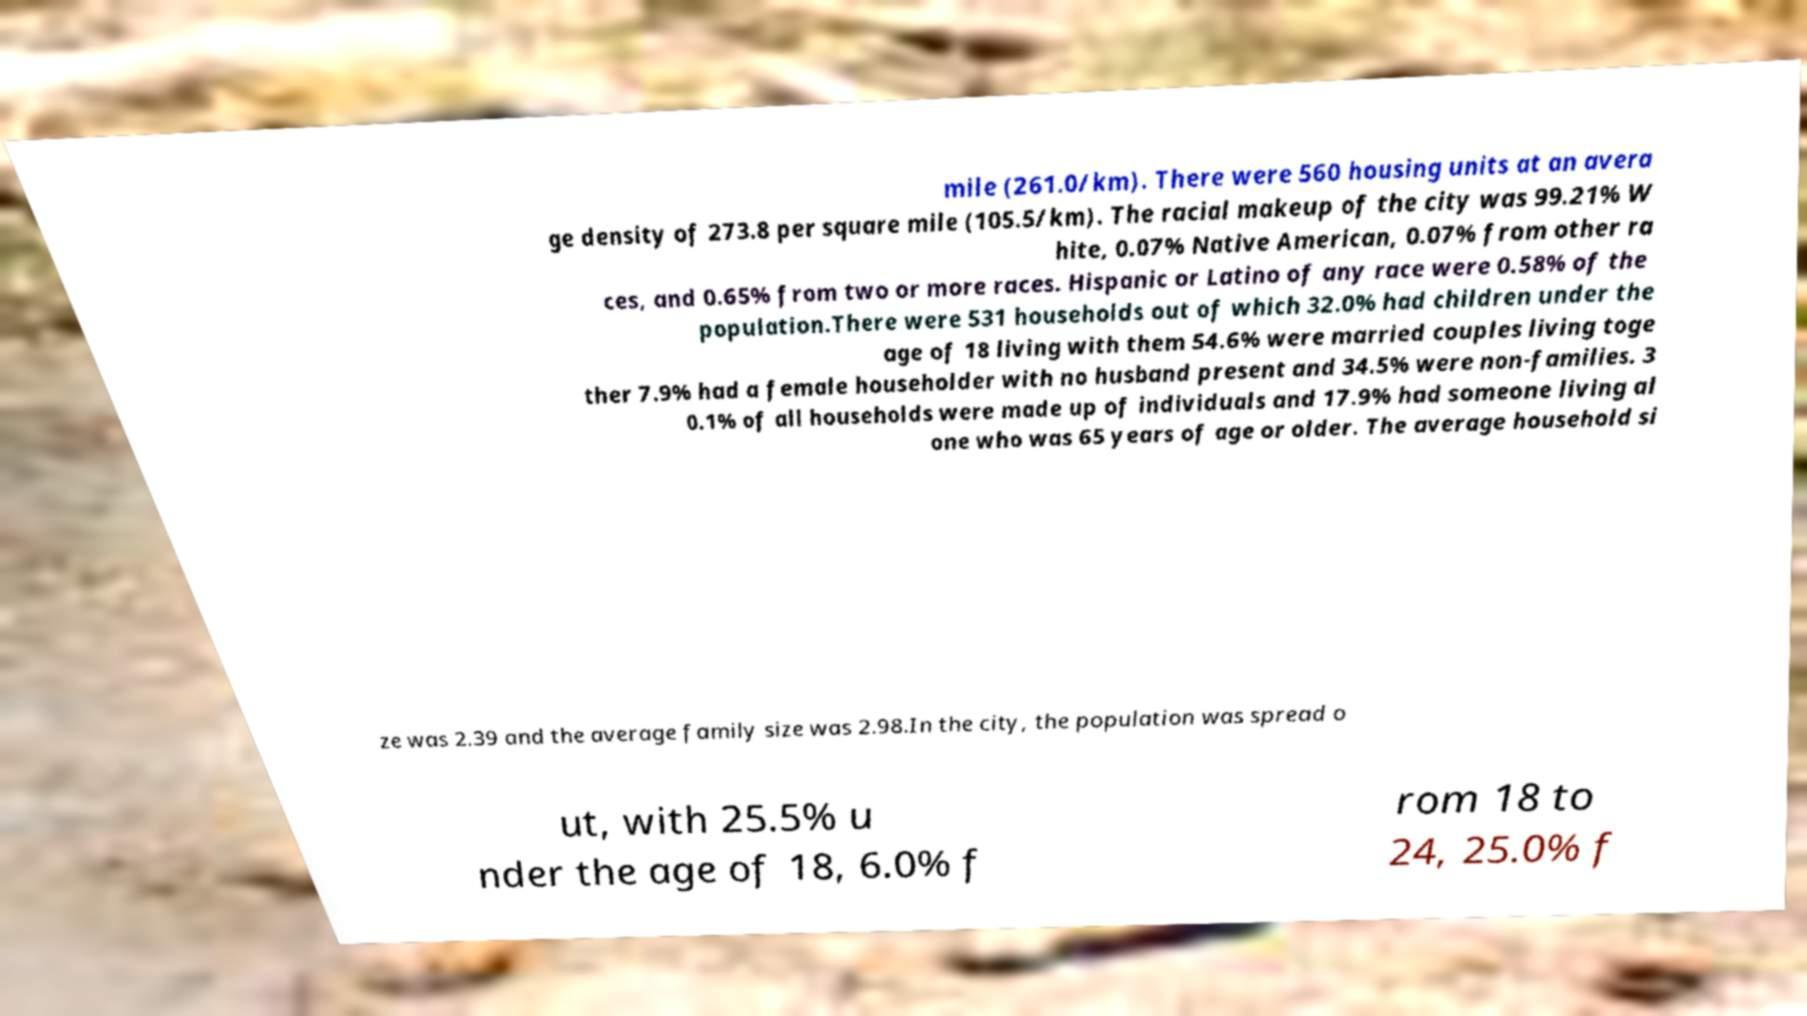I need the written content from this picture converted into text. Can you do that? mile (261.0/km). There were 560 housing units at an avera ge density of 273.8 per square mile (105.5/km). The racial makeup of the city was 99.21% W hite, 0.07% Native American, 0.07% from other ra ces, and 0.65% from two or more races. Hispanic or Latino of any race were 0.58% of the population.There were 531 households out of which 32.0% had children under the age of 18 living with them 54.6% were married couples living toge ther 7.9% had a female householder with no husband present and 34.5% were non-families. 3 0.1% of all households were made up of individuals and 17.9% had someone living al one who was 65 years of age or older. The average household si ze was 2.39 and the average family size was 2.98.In the city, the population was spread o ut, with 25.5% u nder the age of 18, 6.0% f rom 18 to 24, 25.0% f 